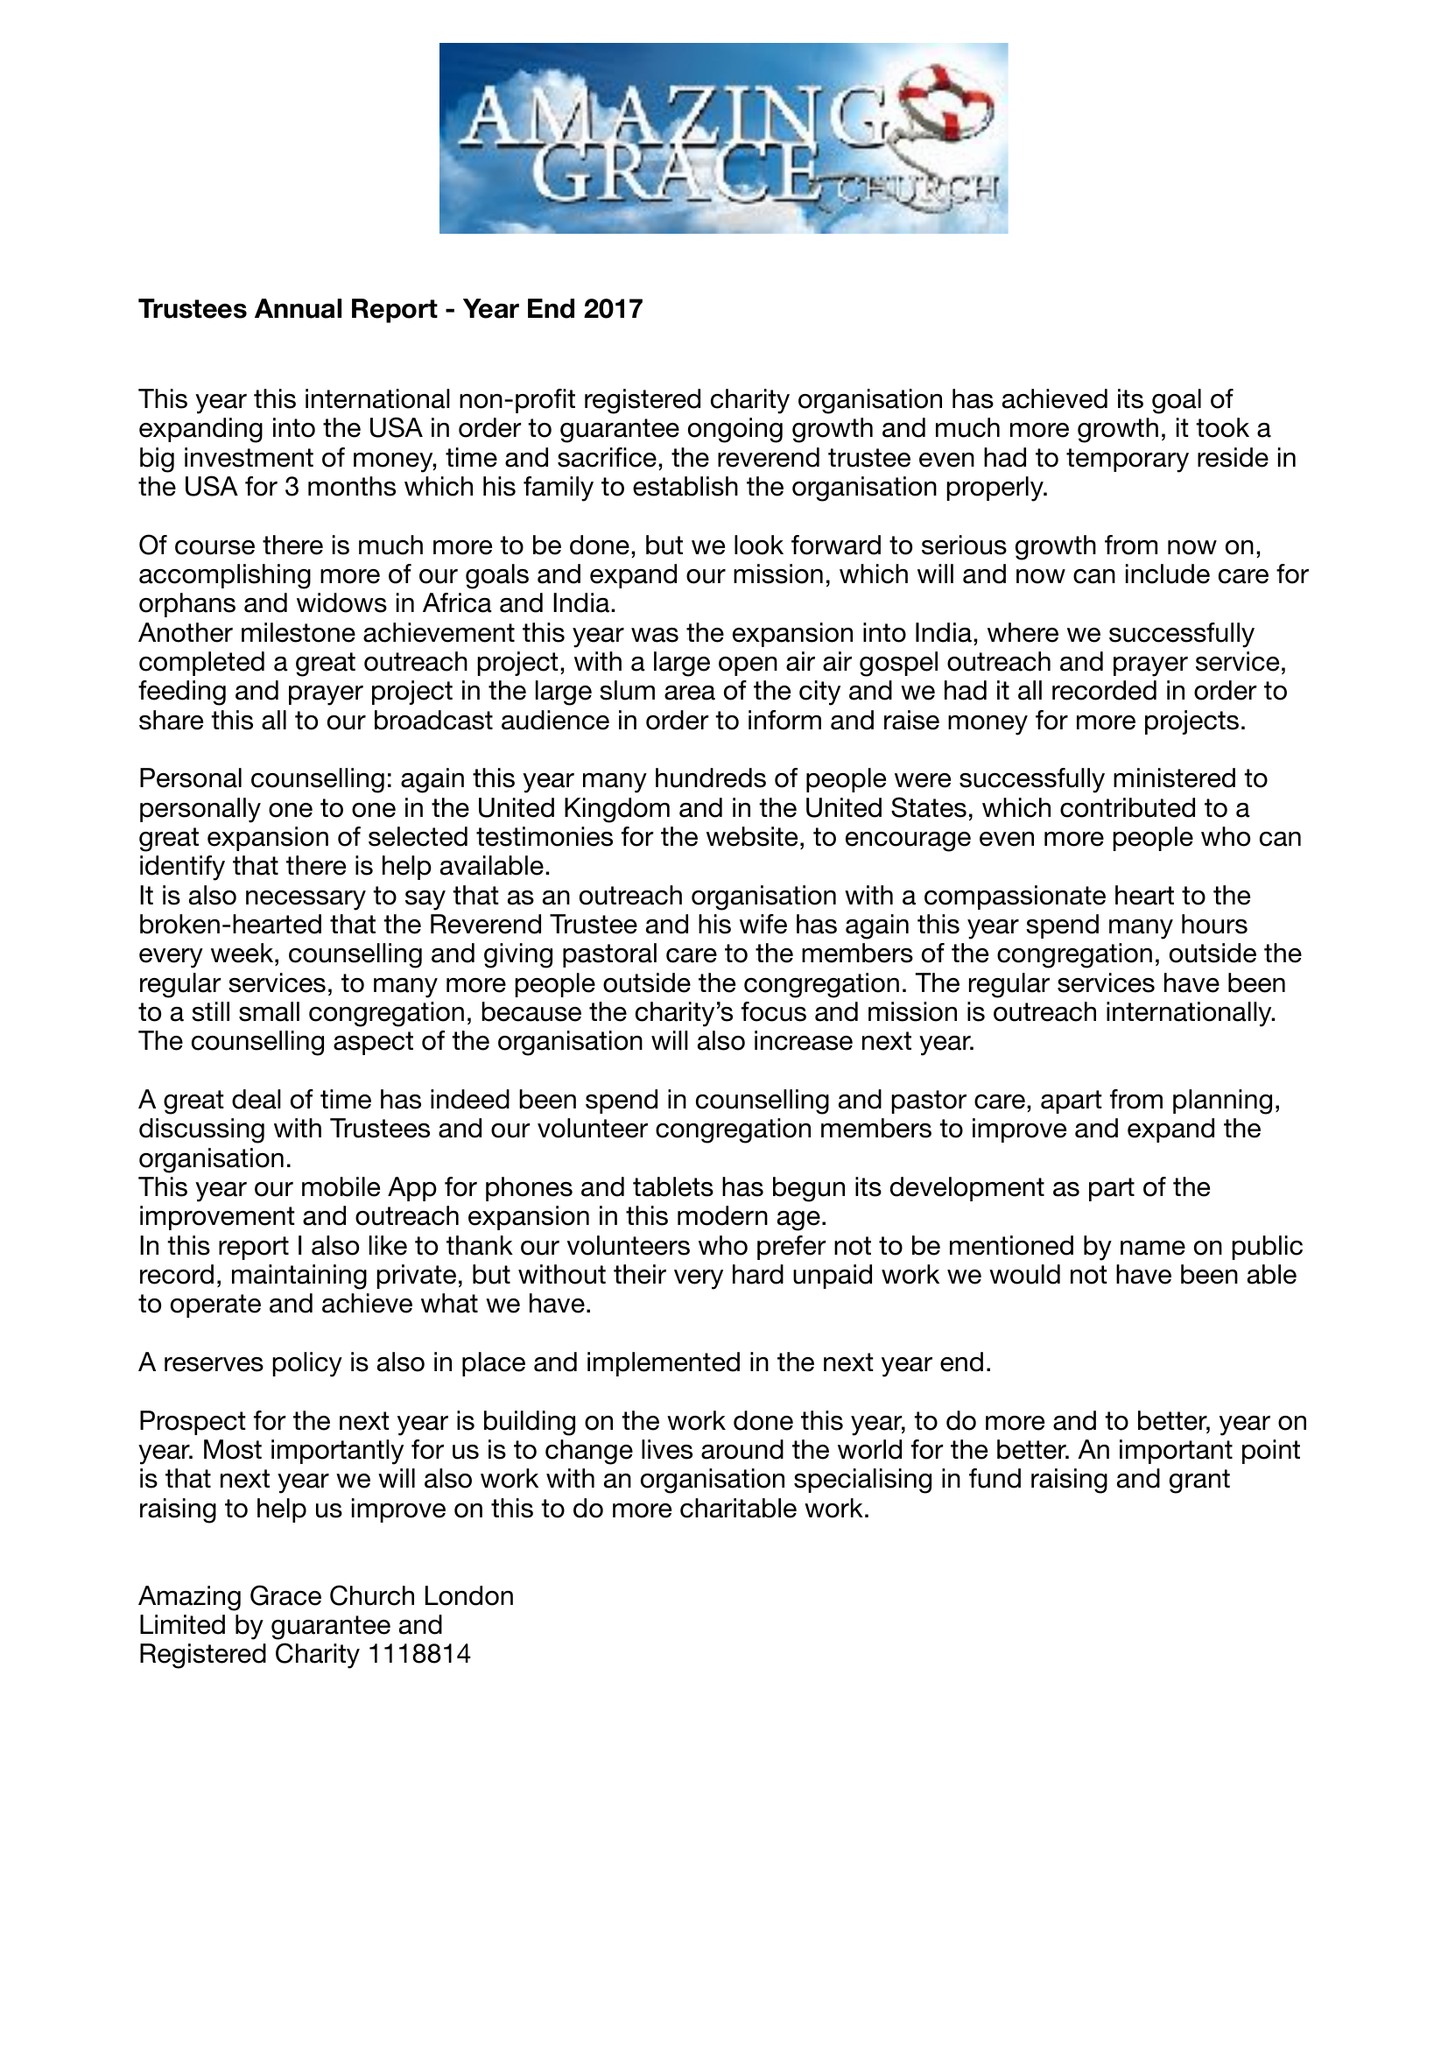What is the value for the charity_name?
Answer the question using a single word or phrase. Amazing Grace Church London 